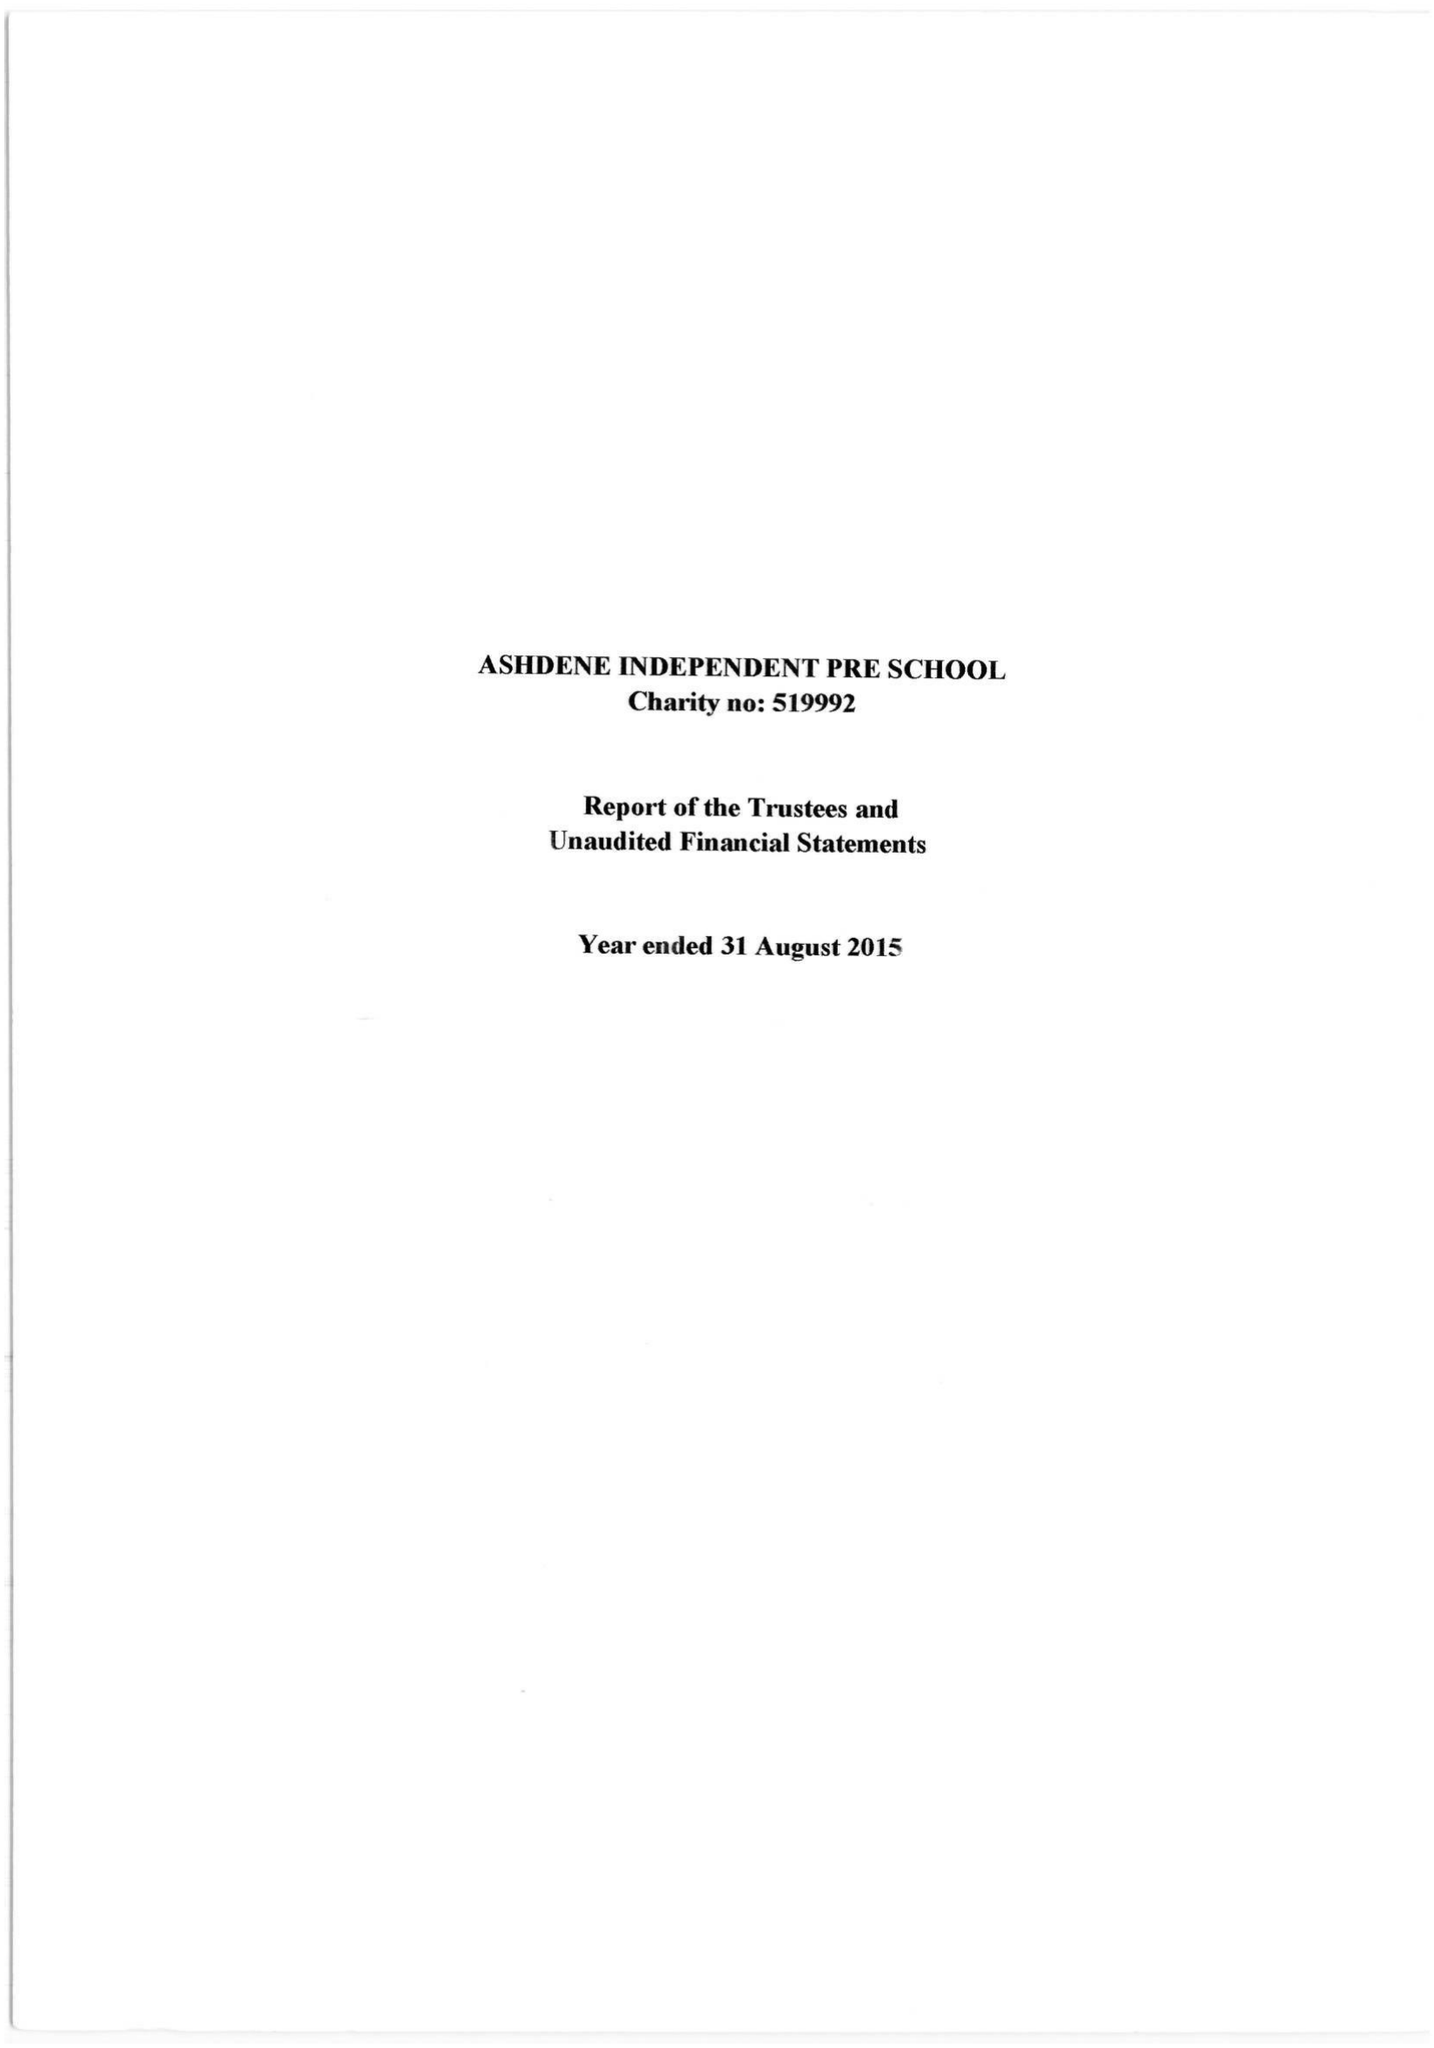What is the value for the charity_number?
Answer the question using a single word or phrase. 519992 